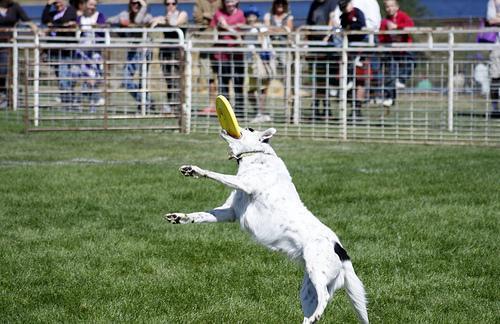How many dogs are there?
Give a very brief answer. 1. 